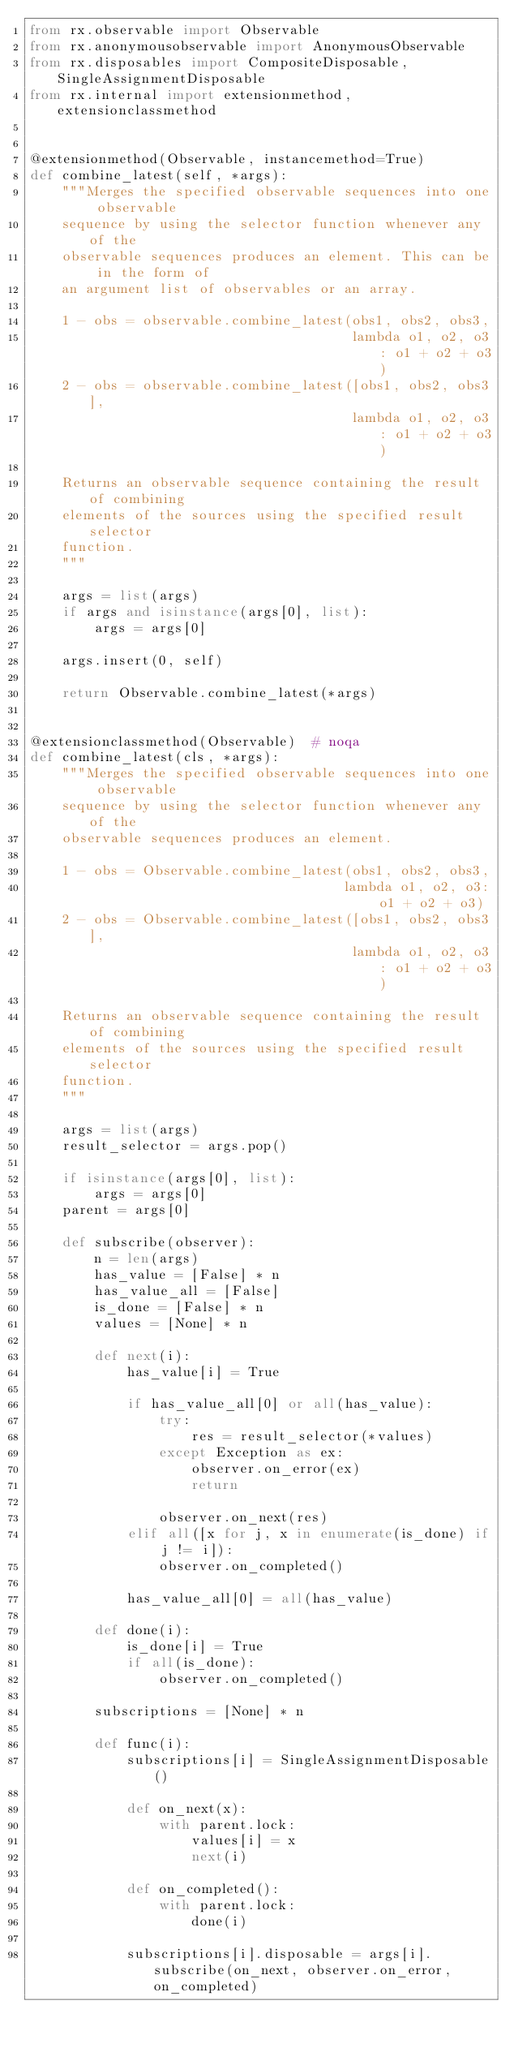Convert code to text. <code><loc_0><loc_0><loc_500><loc_500><_Python_>from rx.observable import Observable
from rx.anonymousobservable import AnonymousObservable
from rx.disposables import CompositeDisposable, SingleAssignmentDisposable
from rx.internal import extensionmethod, extensionclassmethod


@extensionmethod(Observable, instancemethod=True)
def combine_latest(self, *args):
    """Merges the specified observable sequences into one observable
    sequence by using the selector function whenever any of the
    observable sequences produces an element. This can be in the form of
    an argument list of observables or an array.

    1 - obs = observable.combine_latest(obs1, obs2, obs3,
                                        lambda o1, o2, o3: o1 + o2 + o3)
    2 - obs = observable.combine_latest([obs1, obs2, obs3],
                                        lambda o1, o2, o3: o1 + o2 + o3)

    Returns an observable sequence containing the result of combining
    elements of the sources using the specified result selector
    function.
    """

    args = list(args)
    if args and isinstance(args[0], list):
        args = args[0]

    args.insert(0, self)

    return Observable.combine_latest(*args)


@extensionclassmethod(Observable)  # noqa
def combine_latest(cls, *args):
    """Merges the specified observable sequences into one observable
    sequence by using the selector function whenever any of the
    observable sequences produces an element.

    1 - obs = Observable.combine_latest(obs1, obs2, obs3,
                                       lambda o1, o2, o3: o1 + o2 + o3)
    2 - obs = Observable.combine_latest([obs1, obs2, obs3],
                                        lambda o1, o2, o3: o1 + o2 + o3)

    Returns an observable sequence containing the result of combining
    elements of the sources using the specified result selector
    function.
    """

    args = list(args)
    result_selector = args.pop()

    if isinstance(args[0], list):
        args = args[0]
    parent = args[0]

    def subscribe(observer):
        n = len(args)
        has_value = [False] * n
        has_value_all = [False]
        is_done = [False] * n
        values = [None] * n

        def next(i):
            has_value[i] = True

            if has_value_all[0] or all(has_value):
                try:
                    res = result_selector(*values)
                except Exception as ex:
                    observer.on_error(ex)
                    return

                observer.on_next(res)
            elif all([x for j, x in enumerate(is_done) if j != i]):
                observer.on_completed()

            has_value_all[0] = all(has_value)

        def done(i):
            is_done[i] = True
            if all(is_done):
                observer.on_completed()

        subscriptions = [None] * n

        def func(i):
            subscriptions[i] = SingleAssignmentDisposable()

            def on_next(x):
                with parent.lock:
                    values[i] = x
                    next(i)

            def on_completed():
                with parent.lock:
                    done(i)

            subscriptions[i].disposable = args[i].subscribe(on_next, observer.on_error, on_completed)
</code> 